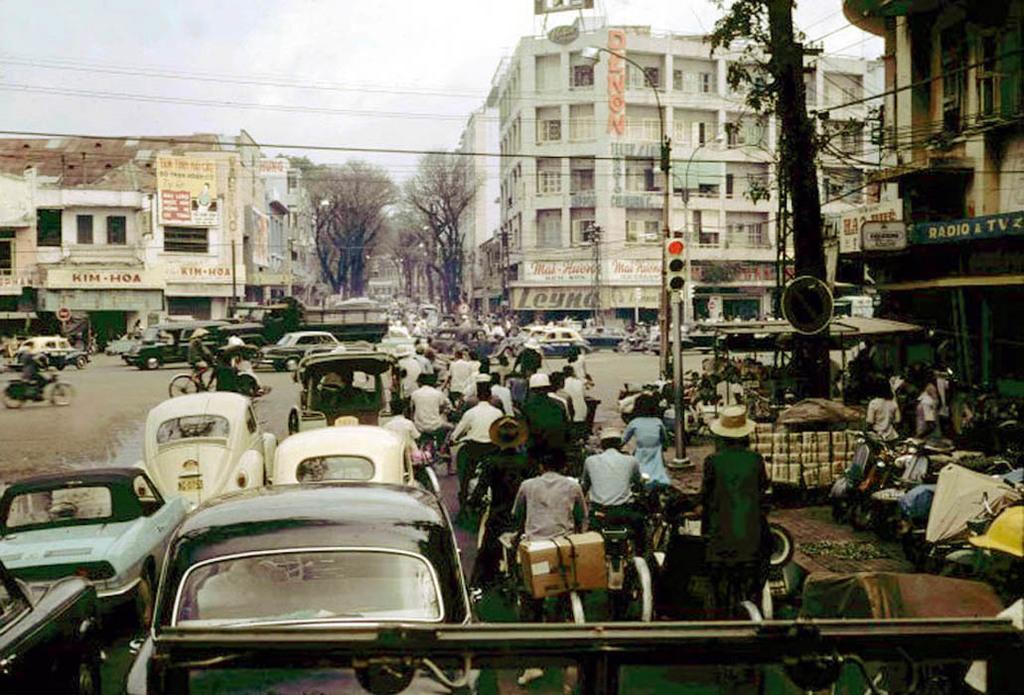How would you summarize this image in a sentence or two? In this image there is the sky towards the top of the image, there are buildings, there are trees, there are poles, there is a street light, there is a traffic light, there are wires, there are boards, there is text on the board, there is a road, there are a group of persons, there are vehicles towards the bottom of the image, there are vehicles towards the right of the image. 